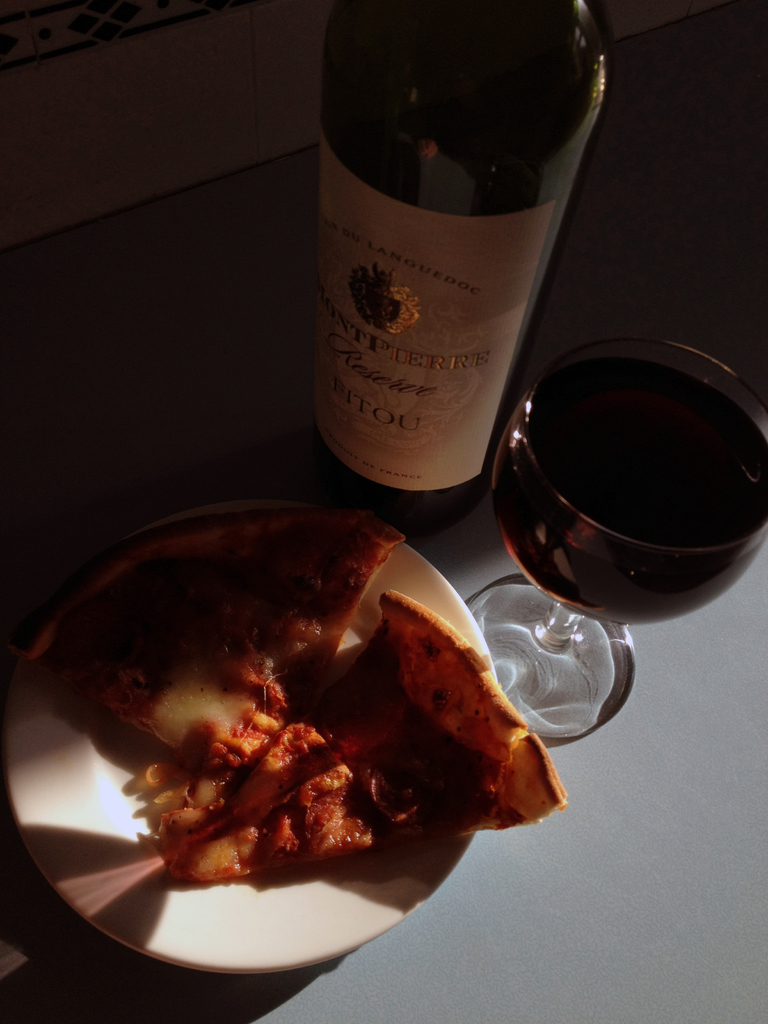Provide a one-sentence caption for the provided image. A glass of rich Montpierre reserve wine, perfectly paired with a slice of hearty pizza, basks in the warm, natural light of a serene afternoon. 